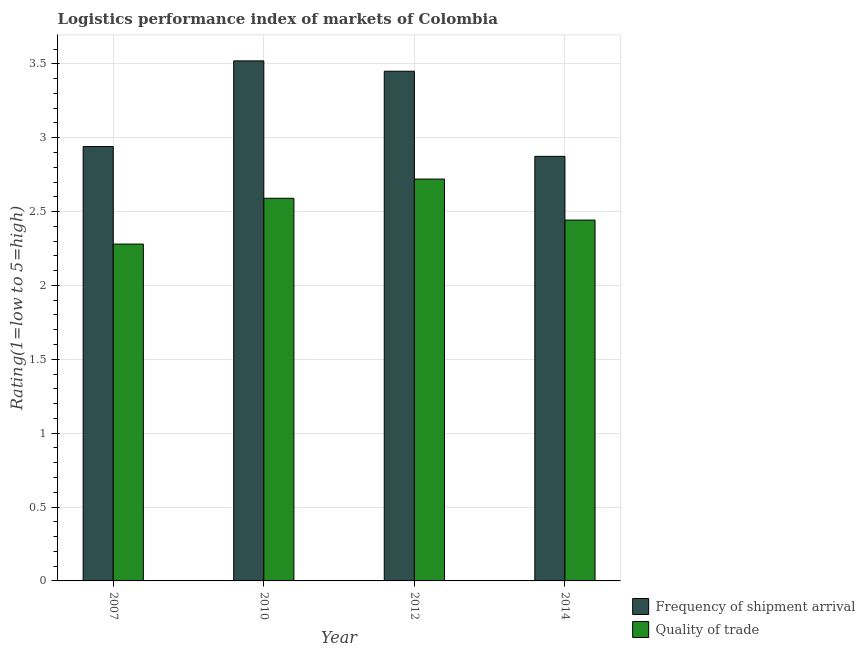How many different coloured bars are there?
Provide a short and direct response. 2. Are the number of bars per tick equal to the number of legend labels?
Your answer should be compact. Yes. How many bars are there on the 3rd tick from the right?
Keep it short and to the point. 2. What is the label of the 3rd group of bars from the left?
Your response must be concise. 2012. In how many cases, is the number of bars for a given year not equal to the number of legend labels?
Keep it short and to the point. 0. What is the lpi quality of trade in 2010?
Provide a succinct answer. 2.59. Across all years, what is the maximum lpi quality of trade?
Keep it short and to the point. 2.72. Across all years, what is the minimum lpi quality of trade?
Provide a short and direct response. 2.28. What is the total lpi quality of trade in the graph?
Offer a terse response. 10.03. What is the difference between the lpi of frequency of shipment arrival in 2010 and that in 2014?
Offer a terse response. 0.65. What is the difference between the lpi of frequency of shipment arrival in 2014 and the lpi quality of trade in 2010?
Ensure brevity in your answer.  -0.65. What is the average lpi quality of trade per year?
Make the answer very short. 2.51. What is the ratio of the lpi of frequency of shipment arrival in 2007 to that in 2012?
Offer a very short reply. 0.85. Is the difference between the lpi of frequency of shipment arrival in 2007 and 2010 greater than the difference between the lpi quality of trade in 2007 and 2010?
Offer a terse response. No. What is the difference between the highest and the second highest lpi quality of trade?
Your response must be concise. 0.13. What is the difference between the highest and the lowest lpi quality of trade?
Your answer should be very brief. 0.44. What does the 2nd bar from the left in 2010 represents?
Offer a terse response. Quality of trade. What does the 1st bar from the right in 2010 represents?
Provide a short and direct response. Quality of trade. How many bars are there?
Ensure brevity in your answer.  8. What is the difference between two consecutive major ticks on the Y-axis?
Provide a succinct answer. 0.5. Does the graph contain any zero values?
Provide a short and direct response. No. Where does the legend appear in the graph?
Offer a terse response. Bottom right. How many legend labels are there?
Provide a succinct answer. 2. What is the title of the graph?
Your response must be concise. Logistics performance index of markets of Colombia. What is the label or title of the X-axis?
Make the answer very short. Year. What is the label or title of the Y-axis?
Provide a short and direct response. Rating(1=low to 5=high). What is the Rating(1=low to 5=high) of Frequency of shipment arrival in 2007?
Your answer should be compact. 2.94. What is the Rating(1=low to 5=high) of Quality of trade in 2007?
Offer a terse response. 2.28. What is the Rating(1=low to 5=high) in Frequency of shipment arrival in 2010?
Make the answer very short. 3.52. What is the Rating(1=low to 5=high) in Quality of trade in 2010?
Provide a short and direct response. 2.59. What is the Rating(1=low to 5=high) of Frequency of shipment arrival in 2012?
Keep it short and to the point. 3.45. What is the Rating(1=low to 5=high) in Quality of trade in 2012?
Keep it short and to the point. 2.72. What is the Rating(1=low to 5=high) in Frequency of shipment arrival in 2014?
Make the answer very short. 2.87. What is the Rating(1=low to 5=high) in Quality of trade in 2014?
Your answer should be compact. 2.44. Across all years, what is the maximum Rating(1=low to 5=high) of Frequency of shipment arrival?
Provide a succinct answer. 3.52. Across all years, what is the maximum Rating(1=low to 5=high) in Quality of trade?
Give a very brief answer. 2.72. Across all years, what is the minimum Rating(1=low to 5=high) in Frequency of shipment arrival?
Provide a succinct answer. 2.87. Across all years, what is the minimum Rating(1=low to 5=high) in Quality of trade?
Provide a succinct answer. 2.28. What is the total Rating(1=low to 5=high) in Frequency of shipment arrival in the graph?
Your answer should be compact. 12.78. What is the total Rating(1=low to 5=high) of Quality of trade in the graph?
Keep it short and to the point. 10.03. What is the difference between the Rating(1=low to 5=high) of Frequency of shipment arrival in 2007 and that in 2010?
Ensure brevity in your answer.  -0.58. What is the difference between the Rating(1=low to 5=high) of Quality of trade in 2007 and that in 2010?
Offer a terse response. -0.31. What is the difference between the Rating(1=low to 5=high) in Frequency of shipment arrival in 2007 and that in 2012?
Provide a succinct answer. -0.51. What is the difference between the Rating(1=low to 5=high) of Quality of trade in 2007 and that in 2012?
Give a very brief answer. -0.44. What is the difference between the Rating(1=low to 5=high) of Frequency of shipment arrival in 2007 and that in 2014?
Your response must be concise. 0.07. What is the difference between the Rating(1=low to 5=high) of Quality of trade in 2007 and that in 2014?
Your answer should be very brief. -0.16. What is the difference between the Rating(1=low to 5=high) in Frequency of shipment arrival in 2010 and that in 2012?
Keep it short and to the point. 0.07. What is the difference between the Rating(1=low to 5=high) of Quality of trade in 2010 and that in 2012?
Give a very brief answer. -0.13. What is the difference between the Rating(1=low to 5=high) in Frequency of shipment arrival in 2010 and that in 2014?
Provide a succinct answer. 0.65. What is the difference between the Rating(1=low to 5=high) in Quality of trade in 2010 and that in 2014?
Your answer should be very brief. 0.15. What is the difference between the Rating(1=low to 5=high) of Frequency of shipment arrival in 2012 and that in 2014?
Your answer should be very brief. 0.58. What is the difference between the Rating(1=low to 5=high) of Quality of trade in 2012 and that in 2014?
Give a very brief answer. 0.28. What is the difference between the Rating(1=low to 5=high) of Frequency of shipment arrival in 2007 and the Rating(1=low to 5=high) of Quality of trade in 2012?
Give a very brief answer. 0.22. What is the difference between the Rating(1=low to 5=high) of Frequency of shipment arrival in 2007 and the Rating(1=low to 5=high) of Quality of trade in 2014?
Ensure brevity in your answer.  0.5. What is the difference between the Rating(1=low to 5=high) of Frequency of shipment arrival in 2010 and the Rating(1=low to 5=high) of Quality of trade in 2014?
Provide a short and direct response. 1.08. What is the difference between the Rating(1=low to 5=high) of Frequency of shipment arrival in 2012 and the Rating(1=low to 5=high) of Quality of trade in 2014?
Offer a very short reply. 1.01. What is the average Rating(1=low to 5=high) of Frequency of shipment arrival per year?
Provide a succinct answer. 3.2. What is the average Rating(1=low to 5=high) of Quality of trade per year?
Your answer should be compact. 2.51. In the year 2007, what is the difference between the Rating(1=low to 5=high) in Frequency of shipment arrival and Rating(1=low to 5=high) in Quality of trade?
Make the answer very short. 0.66. In the year 2012, what is the difference between the Rating(1=low to 5=high) in Frequency of shipment arrival and Rating(1=low to 5=high) in Quality of trade?
Keep it short and to the point. 0.73. In the year 2014, what is the difference between the Rating(1=low to 5=high) in Frequency of shipment arrival and Rating(1=low to 5=high) in Quality of trade?
Provide a succinct answer. 0.43. What is the ratio of the Rating(1=low to 5=high) in Frequency of shipment arrival in 2007 to that in 2010?
Give a very brief answer. 0.84. What is the ratio of the Rating(1=low to 5=high) of Quality of trade in 2007 to that in 2010?
Give a very brief answer. 0.88. What is the ratio of the Rating(1=low to 5=high) in Frequency of shipment arrival in 2007 to that in 2012?
Make the answer very short. 0.85. What is the ratio of the Rating(1=low to 5=high) in Quality of trade in 2007 to that in 2012?
Give a very brief answer. 0.84. What is the ratio of the Rating(1=low to 5=high) of Quality of trade in 2007 to that in 2014?
Provide a succinct answer. 0.93. What is the ratio of the Rating(1=low to 5=high) of Frequency of shipment arrival in 2010 to that in 2012?
Your answer should be very brief. 1.02. What is the ratio of the Rating(1=low to 5=high) in Quality of trade in 2010 to that in 2012?
Provide a succinct answer. 0.95. What is the ratio of the Rating(1=low to 5=high) of Frequency of shipment arrival in 2010 to that in 2014?
Provide a succinct answer. 1.22. What is the ratio of the Rating(1=low to 5=high) of Quality of trade in 2010 to that in 2014?
Your answer should be very brief. 1.06. What is the ratio of the Rating(1=low to 5=high) of Frequency of shipment arrival in 2012 to that in 2014?
Your response must be concise. 1.2. What is the ratio of the Rating(1=low to 5=high) in Quality of trade in 2012 to that in 2014?
Provide a succinct answer. 1.11. What is the difference between the highest and the second highest Rating(1=low to 5=high) in Frequency of shipment arrival?
Make the answer very short. 0.07. What is the difference between the highest and the second highest Rating(1=low to 5=high) of Quality of trade?
Make the answer very short. 0.13. What is the difference between the highest and the lowest Rating(1=low to 5=high) in Frequency of shipment arrival?
Keep it short and to the point. 0.65. What is the difference between the highest and the lowest Rating(1=low to 5=high) in Quality of trade?
Ensure brevity in your answer.  0.44. 